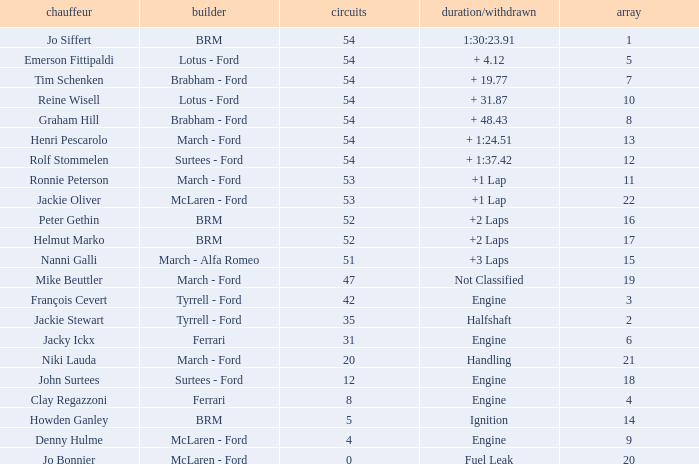Parse the full table. {'header': ['chauffeur', 'builder', 'circuits', 'duration/withdrawn', 'array'], 'rows': [['Jo Siffert', 'BRM', '54', '1:30:23.91', '1'], ['Emerson Fittipaldi', 'Lotus - Ford', '54', '+ 4.12', '5'], ['Tim Schenken', 'Brabham - Ford', '54', '+ 19.77', '7'], ['Reine Wisell', 'Lotus - Ford', '54', '+ 31.87', '10'], ['Graham Hill', 'Brabham - Ford', '54', '+ 48.43', '8'], ['Henri Pescarolo', 'March - Ford', '54', '+ 1:24.51', '13'], ['Rolf Stommelen', 'Surtees - Ford', '54', '+ 1:37.42', '12'], ['Ronnie Peterson', 'March - Ford', '53', '+1 Lap', '11'], ['Jackie Oliver', 'McLaren - Ford', '53', '+1 Lap', '22'], ['Peter Gethin', 'BRM', '52', '+2 Laps', '16'], ['Helmut Marko', 'BRM', '52', '+2 Laps', '17'], ['Nanni Galli', 'March - Alfa Romeo', '51', '+3 Laps', '15'], ['Mike Beuttler', 'March - Ford', '47', 'Not Classified', '19'], ['François Cevert', 'Tyrrell - Ford', '42', 'Engine', '3'], ['Jackie Stewart', 'Tyrrell - Ford', '35', 'Halfshaft', '2'], ['Jacky Ickx', 'Ferrari', '31', 'Engine', '6'], ['Niki Lauda', 'March - Ford', '20', 'Handling', '21'], ['John Surtees', 'Surtees - Ford', '12', 'Engine', '18'], ['Clay Regazzoni', 'Ferrari', '8', 'Engine', '4'], ['Howden Ganley', 'BRM', '5', 'Ignition', '14'], ['Denny Hulme', 'McLaren - Ford', '4', 'Engine', '9'], ['Jo Bonnier', 'McLaren - Ford', '0', 'Fuel Leak', '20']]} What is the average grid that has over 8 laps, a Time/Retired of +2 laps, and peter gethin driving? 16.0. 